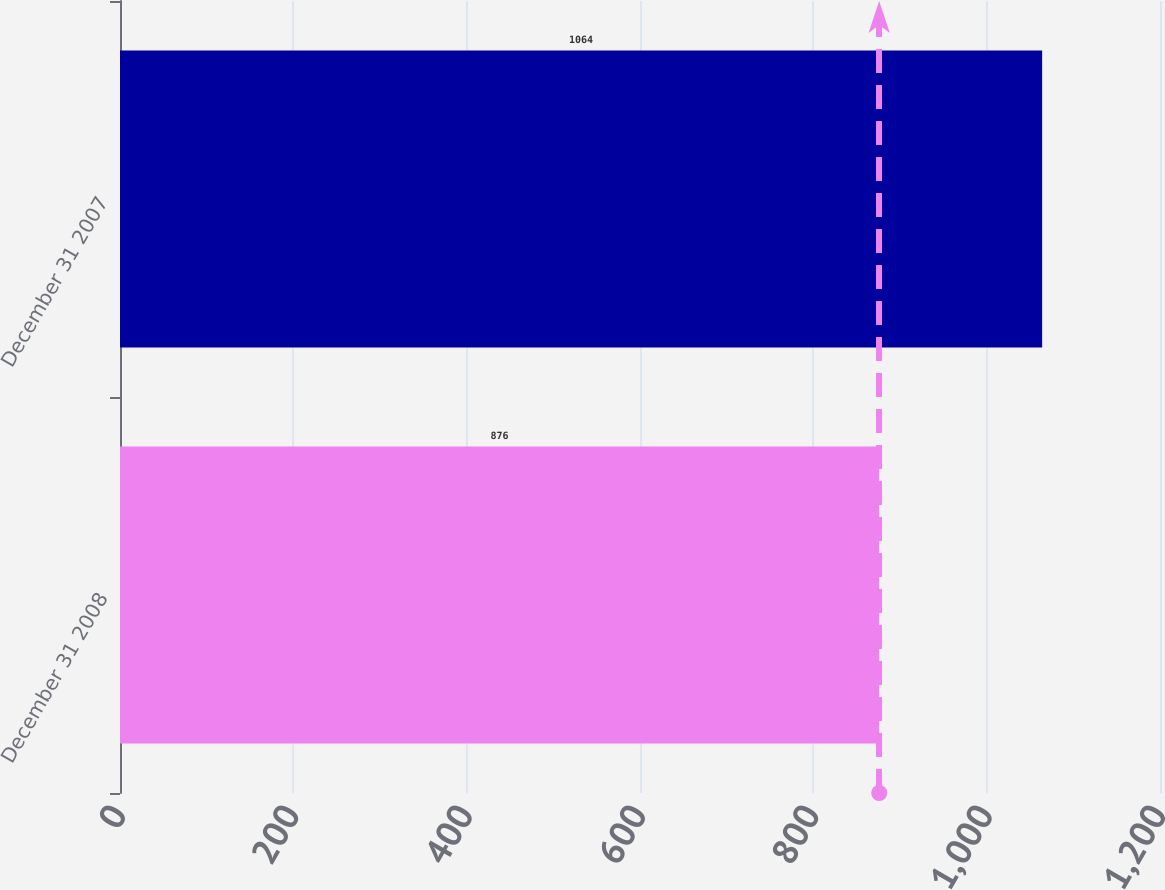Convert chart to OTSL. <chart><loc_0><loc_0><loc_500><loc_500><bar_chart><fcel>December 31 2008<fcel>December 31 2007<nl><fcel>876<fcel>1064<nl></chart> 